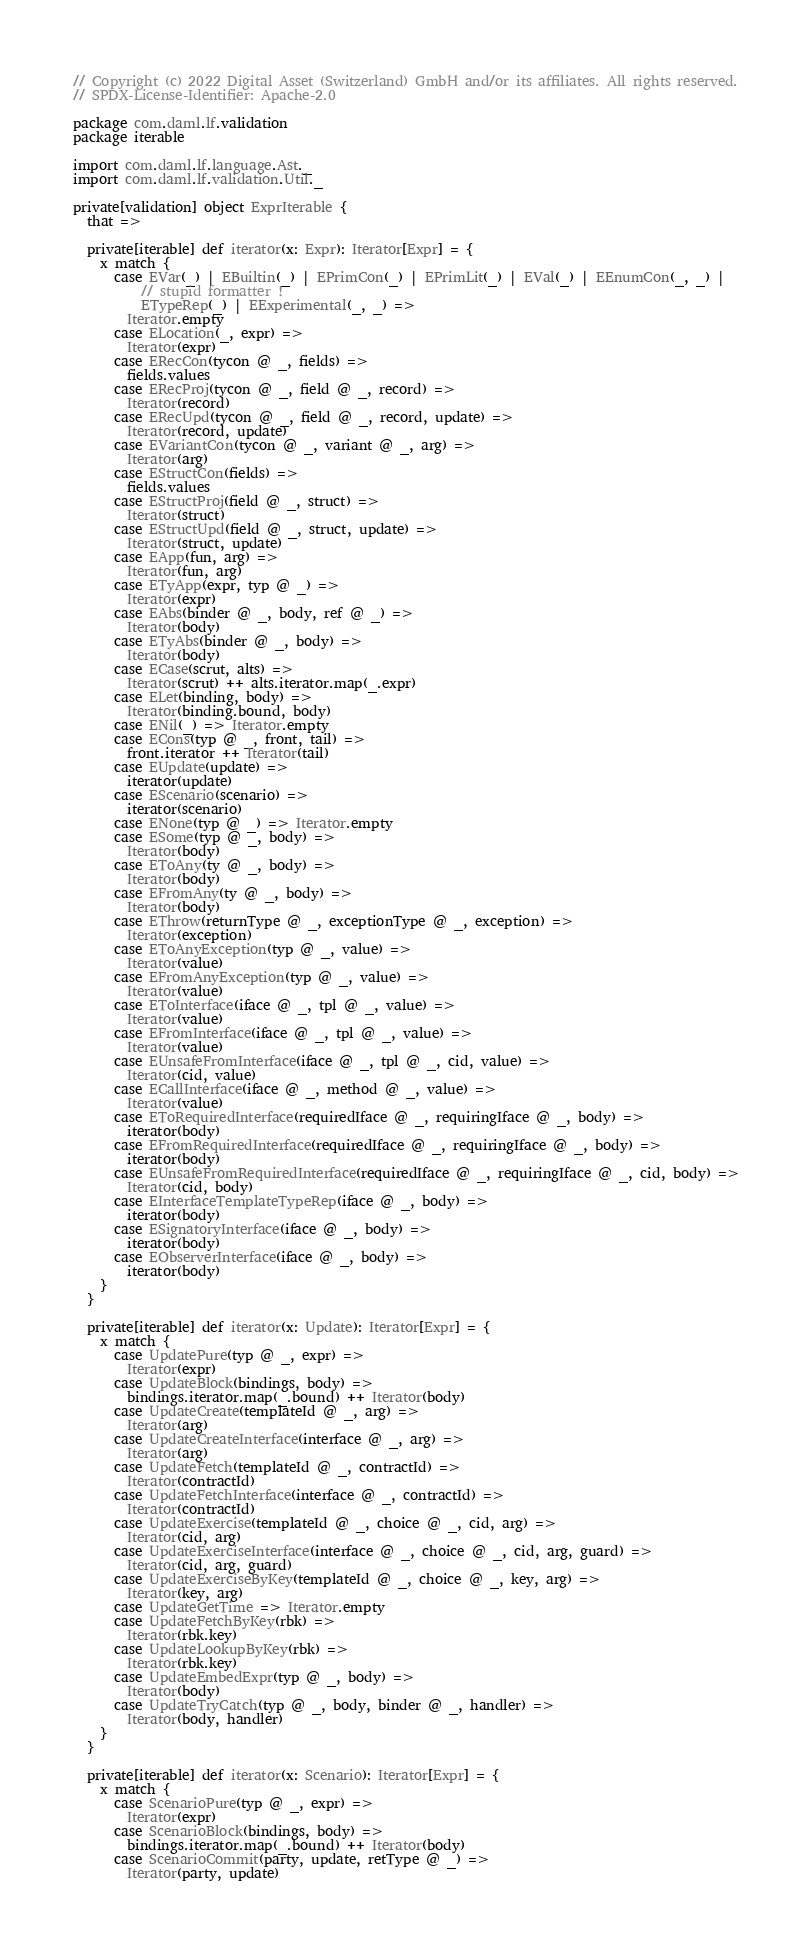Convert code to text. <code><loc_0><loc_0><loc_500><loc_500><_Scala_>// Copyright (c) 2022 Digital Asset (Switzerland) GmbH and/or its affiliates. All rights reserved.
// SPDX-License-Identifier: Apache-2.0

package com.daml.lf.validation
package iterable

import com.daml.lf.language.Ast._
import com.daml.lf.validation.Util._

private[validation] object ExprIterable {
  that =>

  private[iterable] def iterator(x: Expr): Iterator[Expr] = {
    x match {
      case EVar(_) | EBuiltin(_) | EPrimCon(_) | EPrimLit(_) | EVal(_) | EEnumCon(_, _) |
          // stupid formatter !
          ETypeRep(_) | EExperimental(_, _) =>
        Iterator.empty
      case ELocation(_, expr) =>
        Iterator(expr)
      case ERecCon(tycon @ _, fields) =>
        fields.values
      case ERecProj(tycon @ _, field @ _, record) =>
        Iterator(record)
      case ERecUpd(tycon @ _, field @ _, record, update) =>
        Iterator(record, update)
      case EVariantCon(tycon @ _, variant @ _, arg) =>
        Iterator(arg)
      case EStructCon(fields) =>
        fields.values
      case EStructProj(field @ _, struct) =>
        Iterator(struct)
      case EStructUpd(field @ _, struct, update) =>
        Iterator(struct, update)
      case EApp(fun, arg) =>
        Iterator(fun, arg)
      case ETyApp(expr, typ @ _) =>
        Iterator(expr)
      case EAbs(binder @ _, body, ref @ _) =>
        Iterator(body)
      case ETyAbs(binder @ _, body) =>
        Iterator(body)
      case ECase(scrut, alts) =>
        Iterator(scrut) ++ alts.iterator.map(_.expr)
      case ELet(binding, body) =>
        Iterator(binding.bound, body)
      case ENil(_) => Iterator.empty
      case ECons(typ @ _, front, tail) =>
        front.iterator ++ Iterator(tail)
      case EUpdate(update) =>
        iterator(update)
      case EScenario(scenario) =>
        iterator(scenario)
      case ENone(typ @ _) => Iterator.empty
      case ESome(typ @ _, body) =>
        Iterator(body)
      case EToAny(ty @ _, body) =>
        Iterator(body)
      case EFromAny(ty @ _, body) =>
        Iterator(body)
      case EThrow(returnType @ _, exceptionType @ _, exception) =>
        Iterator(exception)
      case EToAnyException(typ @ _, value) =>
        Iterator(value)
      case EFromAnyException(typ @ _, value) =>
        Iterator(value)
      case EToInterface(iface @ _, tpl @ _, value) =>
        Iterator(value)
      case EFromInterface(iface @ _, tpl @ _, value) =>
        Iterator(value)
      case EUnsafeFromInterface(iface @ _, tpl @ _, cid, value) =>
        Iterator(cid, value)
      case ECallInterface(iface @ _, method @ _, value) =>
        Iterator(value)
      case EToRequiredInterface(requiredIface @ _, requiringIface @ _, body) =>
        iterator(body)
      case EFromRequiredInterface(requiredIface @ _, requiringIface @ _, body) =>
        iterator(body)
      case EUnsafeFromRequiredInterface(requiredIface @ _, requiringIface @ _, cid, body) =>
        Iterator(cid, body)
      case EInterfaceTemplateTypeRep(iface @ _, body) =>
        iterator(body)
      case ESignatoryInterface(iface @ _, body) =>
        iterator(body)
      case EObserverInterface(iface @ _, body) =>
        iterator(body)
    }
  }

  private[iterable] def iterator(x: Update): Iterator[Expr] = {
    x match {
      case UpdatePure(typ @ _, expr) =>
        Iterator(expr)
      case UpdateBlock(bindings, body) =>
        bindings.iterator.map(_.bound) ++ Iterator(body)
      case UpdateCreate(templateId @ _, arg) =>
        Iterator(arg)
      case UpdateCreateInterface(interface @ _, arg) =>
        Iterator(arg)
      case UpdateFetch(templateId @ _, contractId) =>
        Iterator(contractId)
      case UpdateFetchInterface(interface @ _, contractId) =>
        Iterator(contractId)
      case UpdateExercise(templateId @ _, choice @ _, cid, arg) =>
        Iterator(cid, arg)
      case UpdateExerciseInterface(interface @ _, choice @ _, cid, arg, guard) =>
        Iterator(cid, arg, guard)
      case UpdateExerciseByKey(templateId @ _, choice @ _, key, arg) =>
        Iterator(key, arg)
      case UpdateGetTime => Iterator.empty
      case UpdateFetchByKey(rbk) =>
        Iterator(rbk.key)
      case UpdateLookupByKey(rbk) =>
        Iterator(rbk.key)
      case UpdateEmbedExpr(typ @ _, body) =>
        Iterator(body)
      case UpdateTryCatch(typ @ _, body, binder @ _, handler) =>
        Iterator(body, handler)
    }
  }

  private[iterable] def iterator(x: Scenario): Iterator[Expr] = {
    x match {
      case ScenarioPure(typ @ _, expr) =>
        Iterator(expr)
      case ScenarioBlock(bindings, body) =>
        bindings.iterator.map(_.bound) ++ Iterator(body)
      case ScenarioCommit(party, update, retType @ _) =>
        Iterator(party, update)</code> 